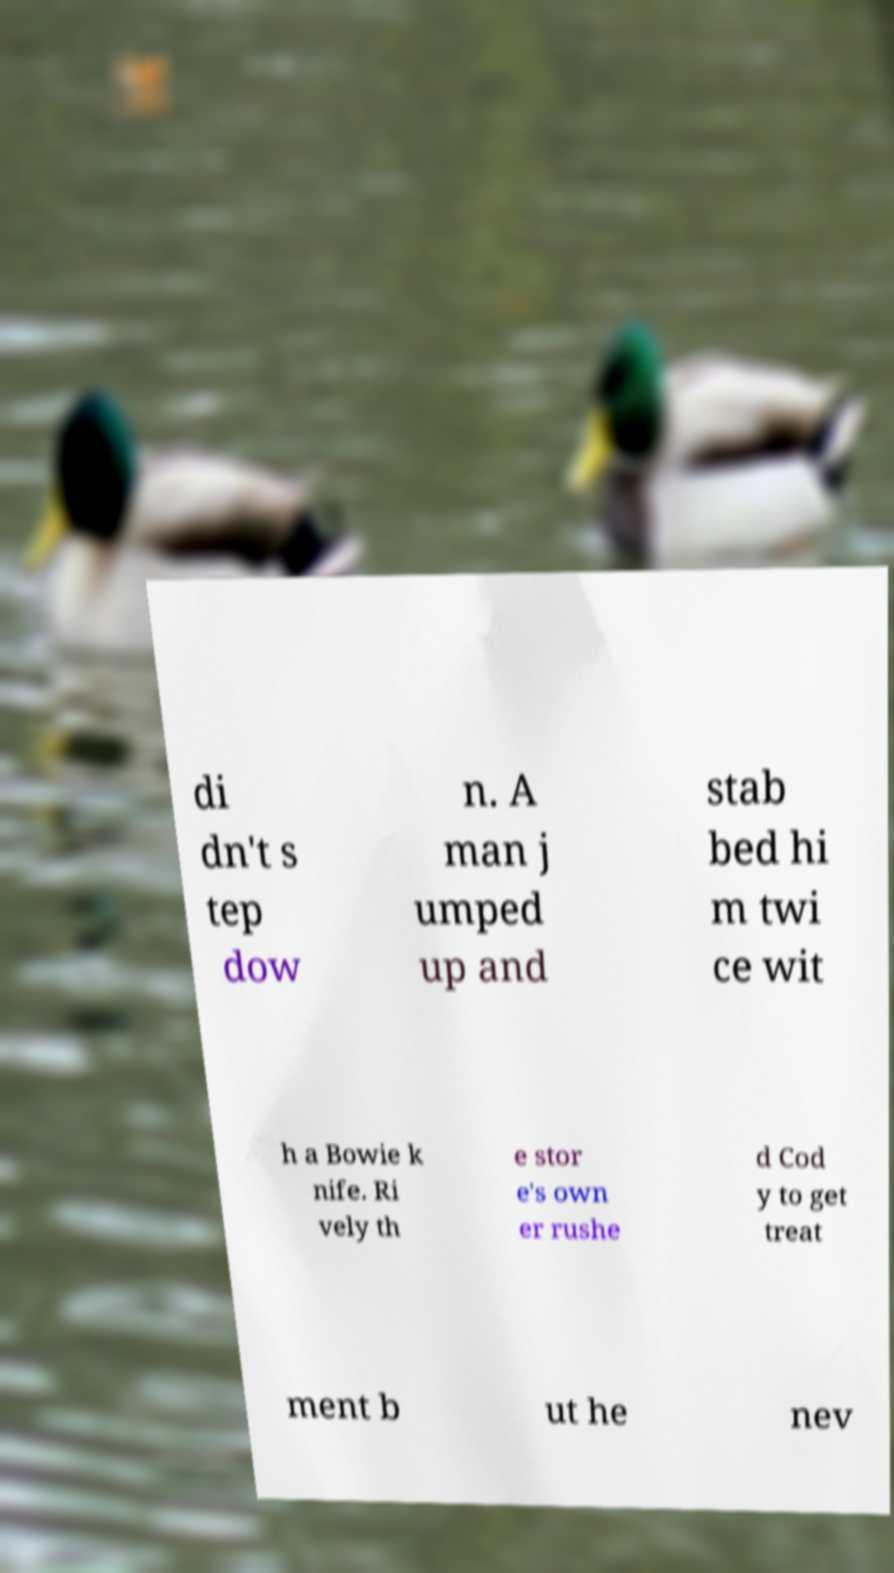What messages or text are displayed in this image? I need them in a readable, typed format. di dn't s tep dow n. A man j umped up and stab bed hi m twi ce wit h a Bowie k nife. Ri vely th e stor e's own er rushe d Cod y to get treat ment b ut he nev 